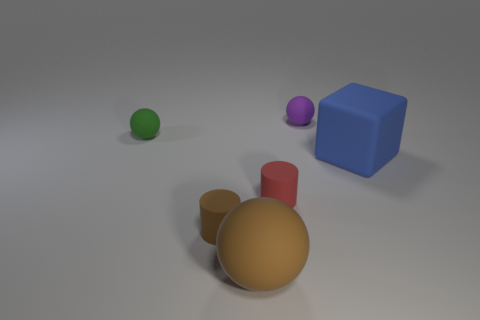Add 2 small green things. How many objects exist? 8 Subtract all blocks. How many objects are left? 5 Add 1 brown cylinders. How many brown cylinders are left? 2 Add 4 large gray rubber spheres. How many large gray rubber spheres exist? 4 Subtract 1 purple balls. How many objects are left? 5 Subtract all tiny purple balls. Subtract all large blue things. How many objects are left? 4 